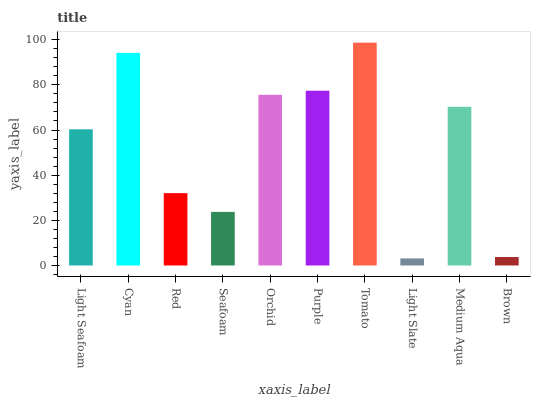Is Light Slate the minimum?
Answer yes or no. Yes. Is Tomato the maximum?
Answer yes or no. Yes. Is Cyan the minimum?
Answer yes or no. No. Is Cyan the maximum?
Answer yes or no. No. Is Cyan greater than Light Seafoam?
Answer yes or no. Yes. Is Light Seafoam less than Cyan?
Answer yes or no. Yes. Is Light Seafoam greater than Cyan?
Answer yes or no. No. Is Cyan less than Light Seafoam?
Answer yes or no. No. Is Medium Aqua the high median?
Answer yes or no. Yes. Is Light Seafoam the low median?
Answer yes or no. Yes. Is Light Slate the high median?
Answer yes or no. No. Is Medium Aqua the low median?
Answer yes or no. No. 